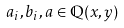Convert formula to latex. <formula><loc_0><loc_0><loc_500><loc_500>a _ { i } , b _ { i } , a \in \mathbb { Q } ( x , y )</formula> 